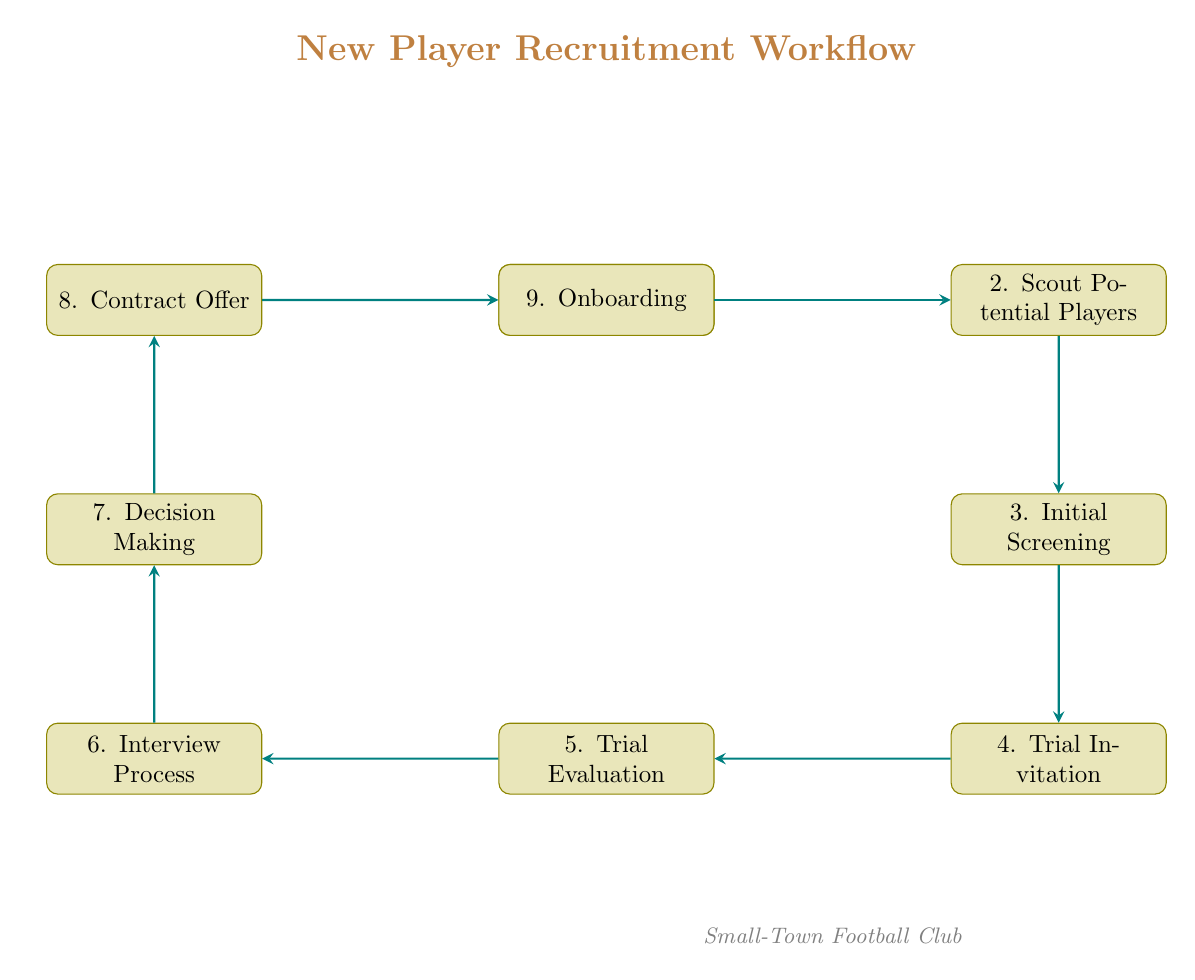What is the first step in the recruitment workflow? The first node in the diagram is "Identify Requirements," indicating that this is the starting point of the recruitment process.
Answer: Identify Requirements How many nodes are there in the diagram? The diagram contains nine nodes, representing the various steps in the New Player Recruitment Workflow.
Answer: Nine What follows after the "Trial Evaluation" step? The node directly below "Trial Evaluation" is "Interview Process," meaning it is the next step in the workflow after evaluating the trial performance.
Answer: Interview Process What is the last step in the recruitment workflow? The last node in the flow chart is "Onboarding," which is the final step following contract acceptance.
Answer: Onboarding What is the relationship between "Scout Potential Players" and "Initial Screening"? The diagram shows an arrow from "Scout Potential Players" to "Initial Screening," indicating that scouting is followed by the initial screening of players.
Answer: Screening Which step involves making the final decision? "Decision Making" is the step where the coaching staff and management team review results and make a decision about the players.
Answer: Decision Making How many edges are in the diagram? The diagram includes eight edges, each representing a connection between two steps in the recruitment process.
Answer: Eight What node comes before "Contract Offer"? The node immediately preceding "Contract Offer" is "Decision Making," indicating that the decision must be made before making a contract offer.
Answer: Decision Making What is the main purpose of the "Onboarding" step? The purpose of "Onboarding" is to integrate the new player into the team, including their training plans and introduction.
Answer: Integrate the new player 